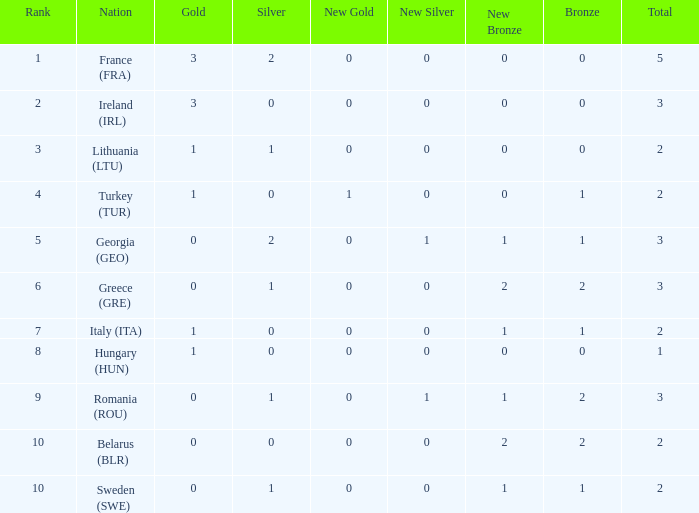What's the total number of bronze medals for Sweden (SWE) having less than 1 gold and silver? 0.0. 